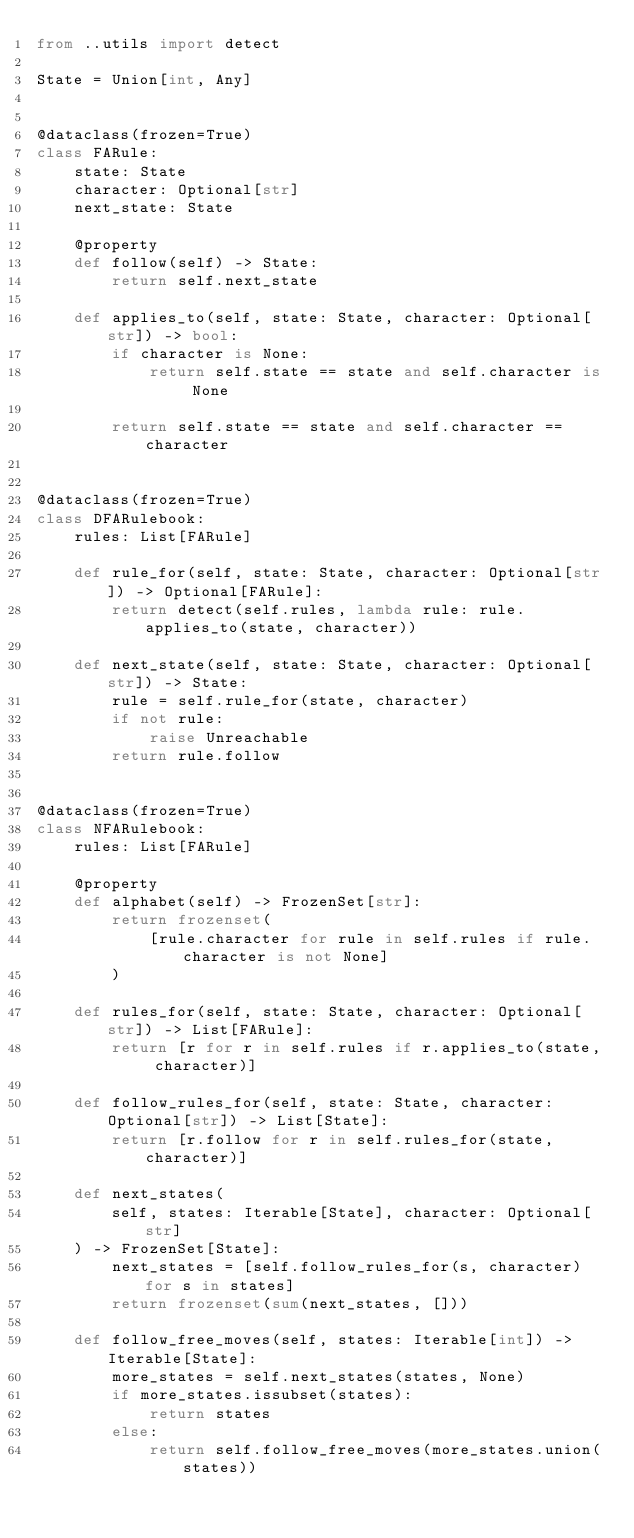<code> <loc_0><loc_0><loc_500><loc_500><_Python_>from ..utils import detect

State = Union[int, Any]


@dataclass(frozen=True)
class FARule:
    state: State
    character: Optional[str]
    next_state: State

    @property
    def follow(self) -> State:
        return self.next_state

    def applies_to(self, state: State, character: Optional[str]) -> bool:
        if character is None:
            return self.state == state and self.character is None

        return self.state == state and self.character == character


@dataclass(frozen=True)
class DFARulebook:
    rules: List[FARule]

    def rule_for(self, state: State, character: Optional[str]) -> Optional[FARule]:
        return detect(self.rules, lambda rule: rule.applies_to(state, character))

    def next_state(self, state: State, character: Optional[str]) -> State:
        rule = self.rule_for(state, character)
        if not rule:
            raise Unreachable
        return rule.follow


@dataclass(frozen=True)
class NFARulebook:
    rules: List[FARule]

    @property
    def alphabet(self) -> FrozenSet[str]:
        return frozenset(
            [rule.character for rule in self.rules if rule.character is not None]
        )

    def rules_for(self, state: State, character: Optional[str]) -> List[FARule]:
        return [r for r in self.rules if r.applies_to(state, character)]

    def follow_rules_for(self, state: State, character: Optional[str]) -> List[State]:
        return [r.follow for r in self.rules_for(state, character)]

    def next_states(
        self, states: Iterable[State], character: Optional[str]
    ) -> FrozenSet[State]:
        next_states = [self.follow_rules_for(s, character) for s in states]
        return frozenset(sum(next_states, []))

    def follow_free_moves(self, states: Iterable[int]) -> Iterable[State]:
        more_states = self.next_states(states, None)
        if more_states.issubset(states):
            return states
        else:
            return self.follow_free_moves(more_states.union(states))
</code> 